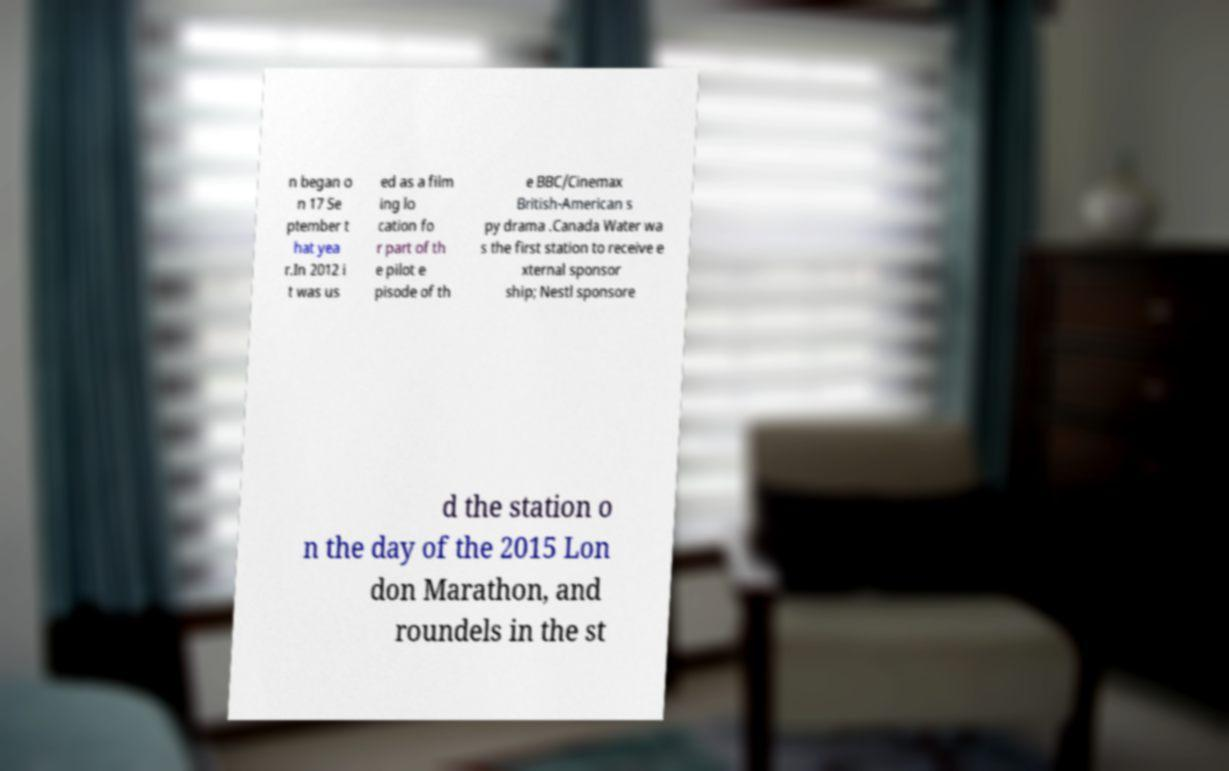Can you accurately transcribe the text from the provided image for me? n began o n 17 Se ptember t hat yea r.In 2012 i t was us ed as a film ing lo cation fo r part of th e pilot e pisode of th e BBC/Cinemax British-American s py drama .Canada Water wa s the first station to receive e xternal sponsor ship; Nestl sponsore d the station o n the day of the 2015 Lon don Marathon, and roundels in the st 